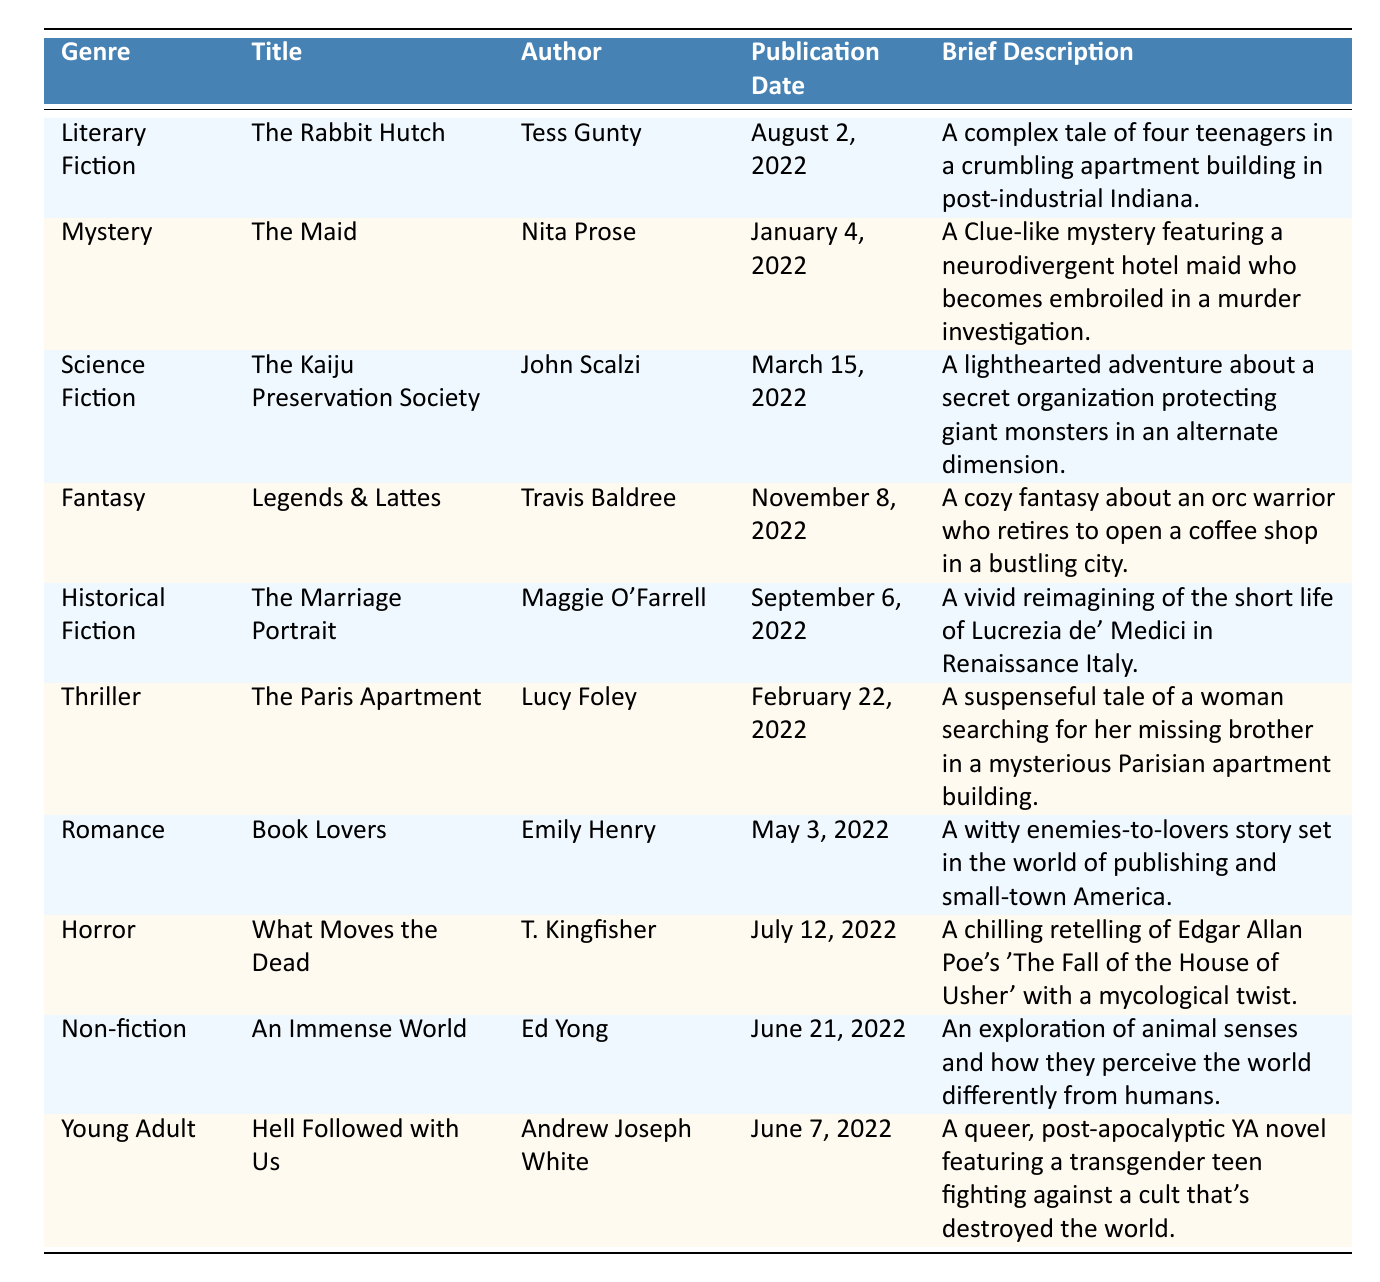What is the title of the book authored by Tess Gunty? The author Tess Gunty wrote "The Rabbit Hutch." This title can be found under the Literary Fiction genre in the table.
Answer: The Rabbit Hutch Which genre does "What Moves the Dead" belong to? "What Moves the Dead" is categorized under the Horror genre, as listed in the table.
Answer: Horror How many books are listed under the genre of Fantasy? There is one book listed under the Fantasy genre, which is "Legends & Lattes." This can be directly observed from the table.
Answer: 1 Who published "The Marriage Portrait"? "The Marriage Portrait" was published by Knopf, as indicated in the publisher column of the table.
Answer: Knopf Is "Hell Followed with Us" a Young Adult novel? Yes, "Hell Followed with Us" is indeed categorized as a Young Adult novel, confirmed by its entry in the table.
Answer: Yes What month was "The Maid" published? "The Maid" was published in January, as shown in the table under the Publication Date for that book.
Answer: January Which book was published the earliest among the listed books? "The Maid" published on January 4, 2022, is the earliest, as it has the earliest date compared to the other entries in the table.
Answer: The Maid Which genre has the most books mentioned in this table? Each genre in the table has only one book listed, so no genre has more than others. This is confirmed by reviewing the entries.
Answer: None What is the publication date of "An Immense World"? "An Immense World" was published on June 21, 2022, as specified in the Publication Date column of the table.
Answer: June 21, 2022 What is the occupation of the protagonist in "The Maid"? The protagonist in "The Maid" is a neurodivergent hotel maid, as described in the brief description for that book in the table.
Answer: Hotel maid Can you find a book published by Tor Books? Yes, "The Kaiju Preservation Society" and "Legends & Lattes" are both published by Tor Books. This information can be reached by searching the Publisher column in the table.
Answer: Yes 